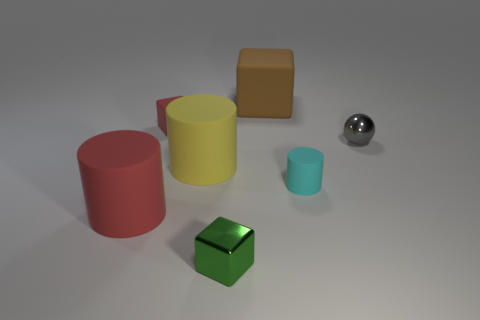The cylinder that is the same color as the tiny matte cube is what size?
Ensure brevity in your answer.  Large. The small thing that is both in front of the tiny sphere and left of the brown rubber cube is made of what material?
Your answer should be compact. Metal. What number of brown blocks are to the left of the large cylinder that is behind the small cylinder?
Your response must be concise. 0. Is there anything else that is the same color as the small matte block?
Your answer should be compact. Yes. There is a big yellow object that is the same material as the red cylinder; what is its shape?
Make the answer very short. Cylinder. Is the tiny green block on the left side of the large brown matte object made of the same material as the thing that is on the right side of the tiny cyan cylinder?
Give a very brief answer. Yes. How many things are big red cylinders or cylinders to the right of the brown object?
Offer a terse response. 2. The large matte thing that is the same color as the tiny matte cube is what shape?
Your response must be concise. Cylinder. What material is the tiny gray sphere?
Your answer should be compact. Metal. Is the material of the brown thing the same as the yellow object?
Make the answer very short. Yes. 